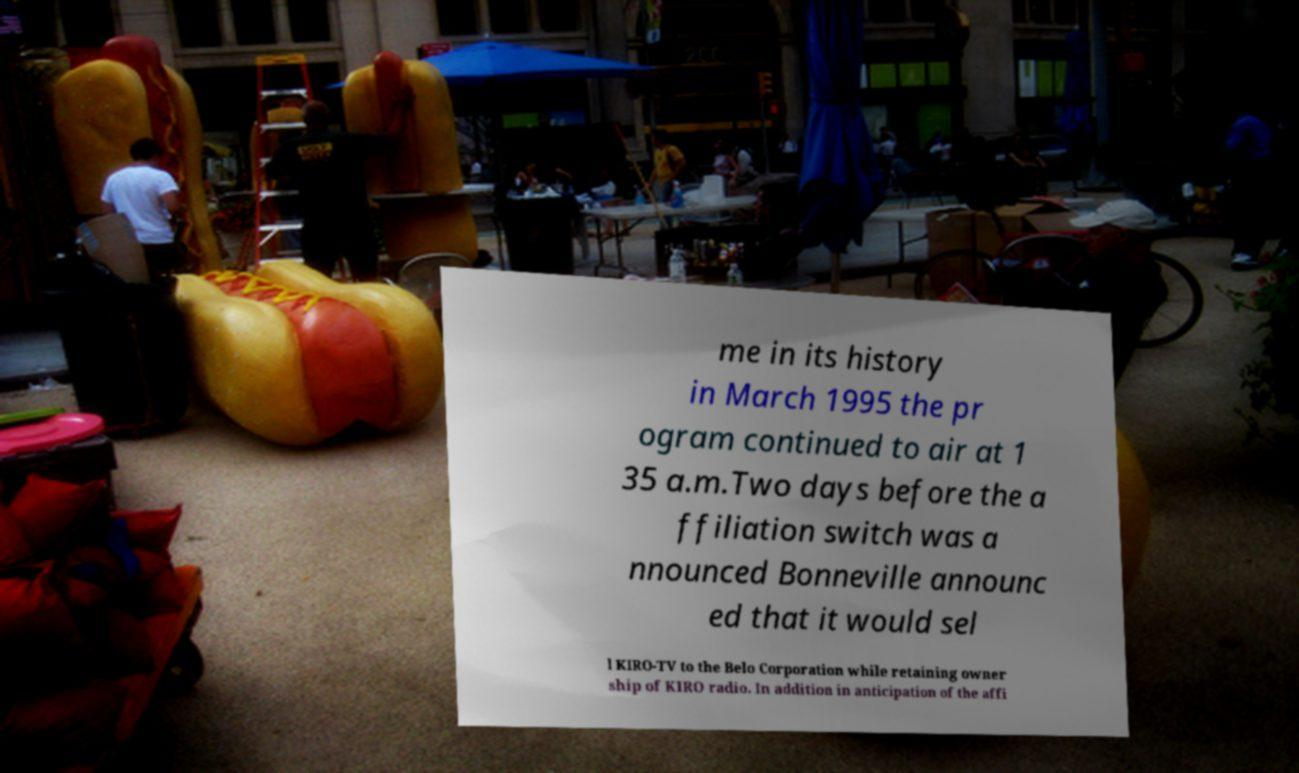For documentation purposes, I need the text within this image transcribed. Could you provide that? me in its history in March 1995 the pr ogram continued to air at 1 35 a.m.Two days before the a ffiliation switch was a nnounced Bonneville announc ed that it would sel l KIRO-TV to the Belo Corporation while retaining owner ship of KIRO radio. In addition in anticipation of the affi 